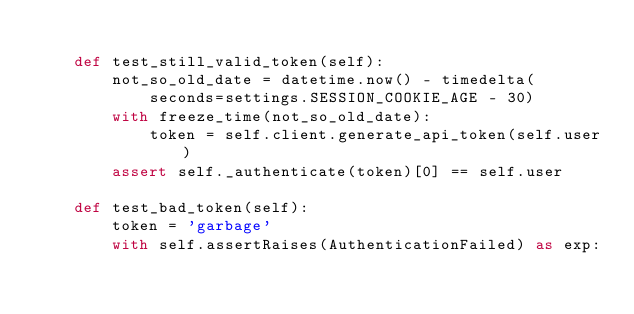<code> <loc_0><loc_0><loc_500><loc_500><_Python_>
    def test_still_valid_token(self):
        not_so_old_date = datetime.now() - timedelta(
            seconds=settings.SESSION_COOKIE_AGE - 30)
        with freeze_time(not_so_old_date):
            token = self.client.generate_api_token(self.user)
        assert self._authenticate(token)[0] == self.user

    def test_bad_token(self):
        token = 'garbage'
        with self.assertRaises(AuthenticationFailed) as exp:</code> 